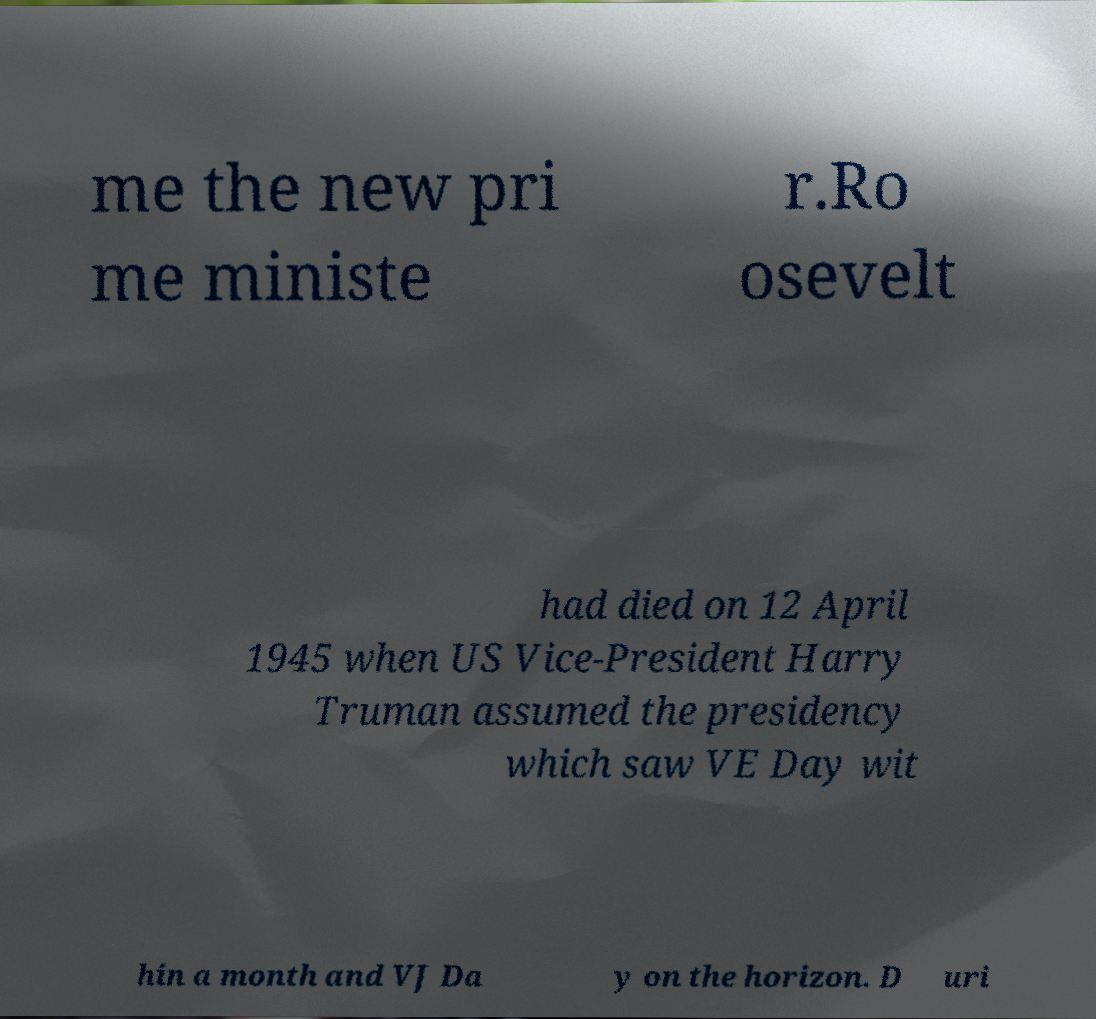For documentation purposes, I need the text within this image transcribed. Could you provide that? me the new pri me ministe r.Ro osevelt had died on 12 April 1945 when US Vice-President Harry Truman assumed the presidency which saw VE Day wit hin a month and VJ Da y on the horizon. D uri 